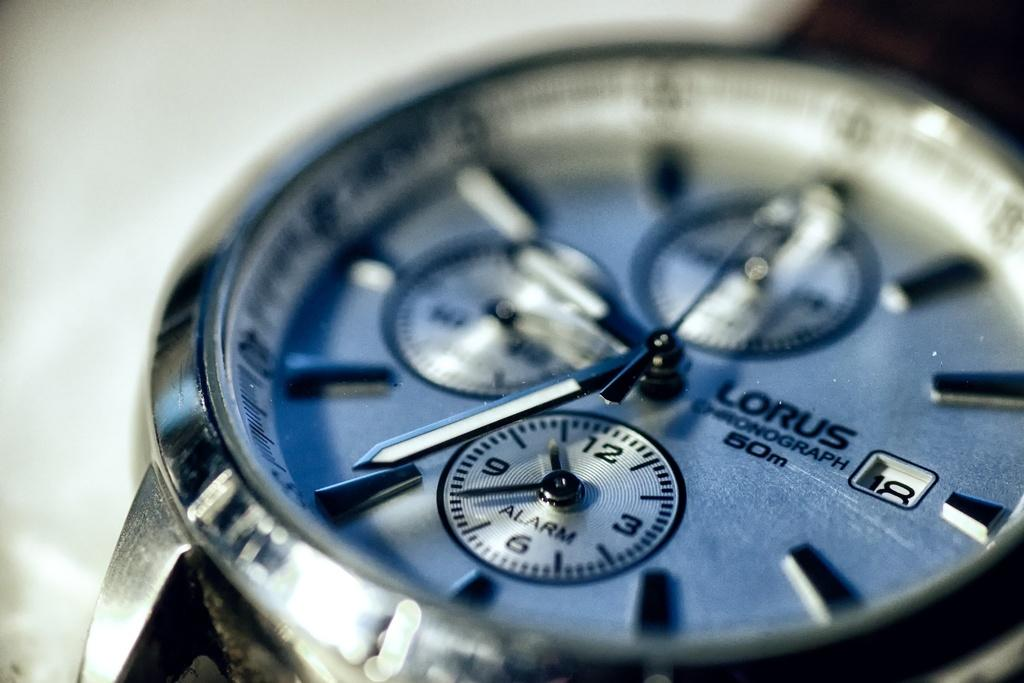<image>
Render a clear and concise summary of the photo. A Lorus watch says that it is a chronograph. 